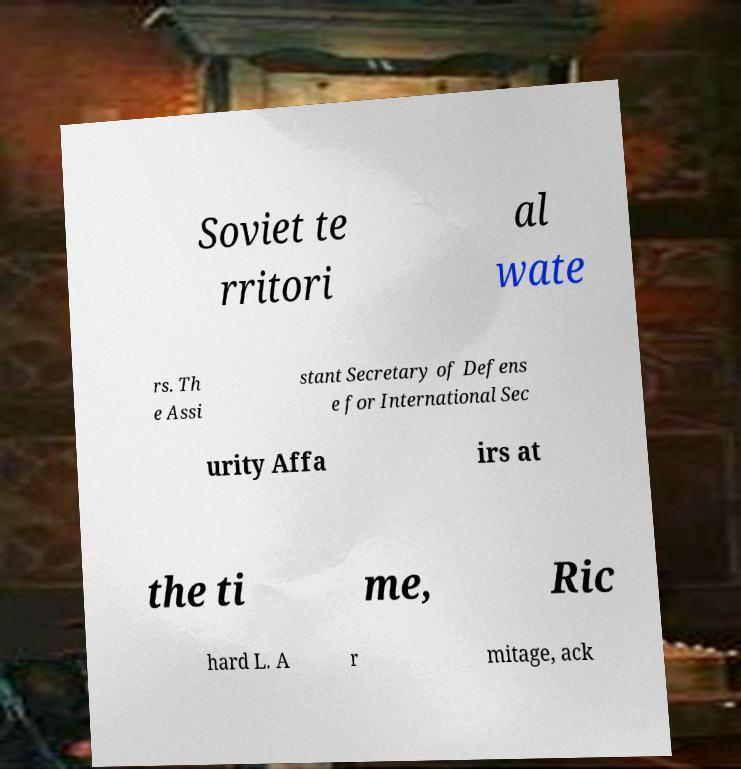Could you extract and type out the text from this image? Soviet te rritori al wate rs. Th e Assi stant Secretary of Defens e for International Sec urity Affa irs at the ti me, Ric hard L. A r mitage, ack 